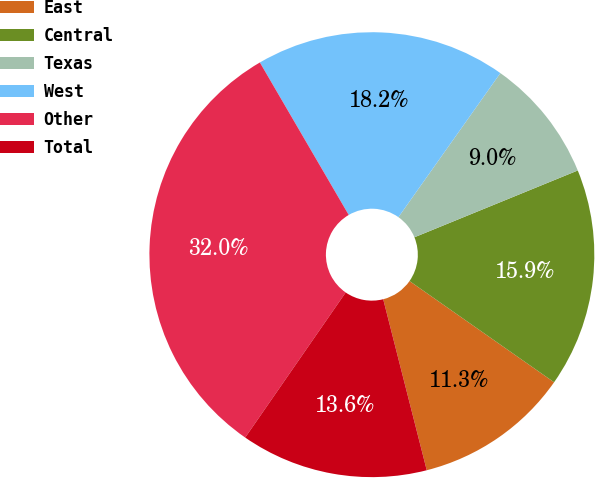Convert chart to OTSL. <chart><loc_0><loc_0><loc_500><loc_500><pie_chart><fcel>East<fcel>Central<fcel>Texas<fcel>West<fcel>Other<fcel>Total<nl><fcel>11.31%<fcel>15.9%<fcel>9.02%<fcel>18.2%<fcel>31.96%<fcel>13.61%<nl></chart> 